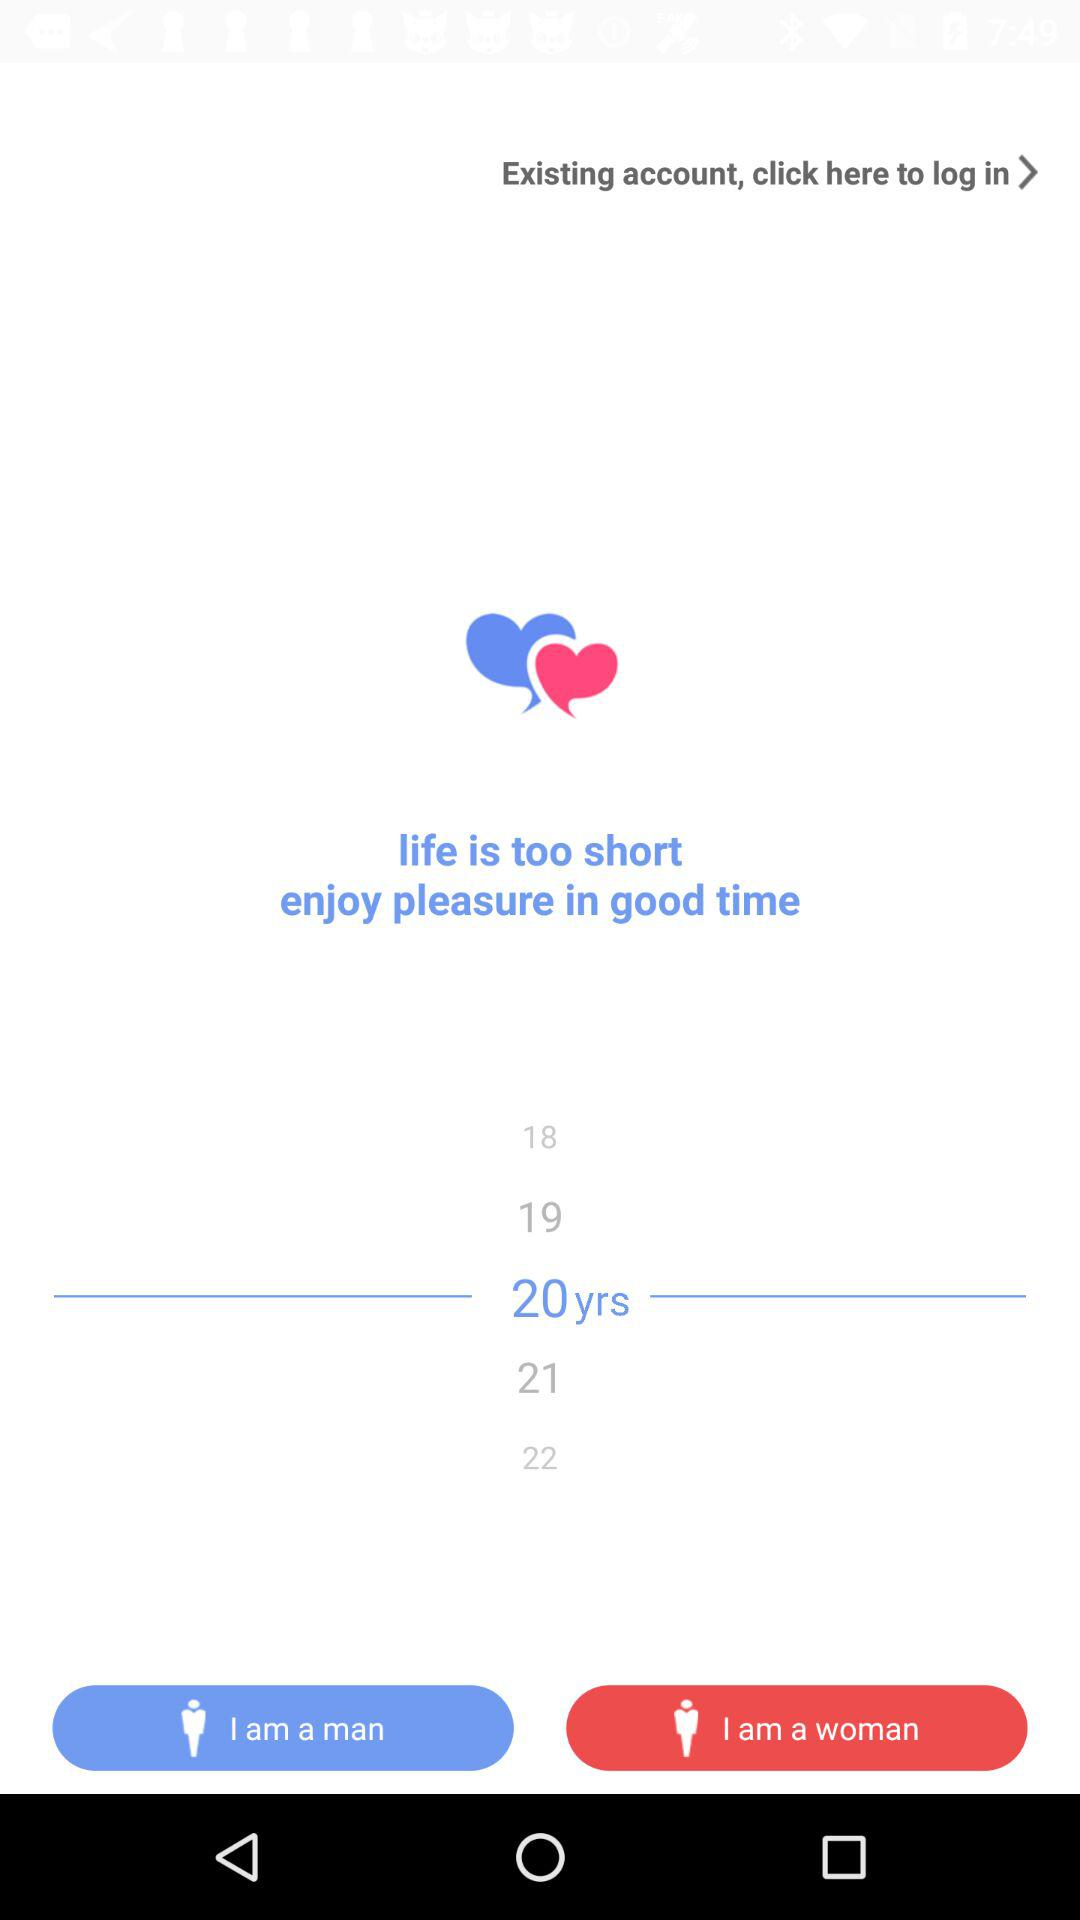Is the user a man or a woman?
When the provided information is insufficient, respond with <no answer>. <no answer> 